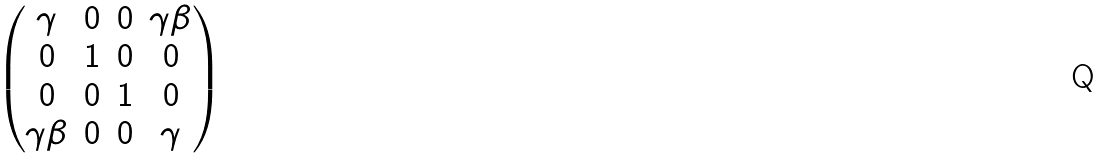<formula> <loc_0><loc_0><loc_500><loc_500>\begin{pmatrix} \gamma & 0 & 0 & \gamma \beta \\ 0 & 1 & 0 & 0 \\ 0 & 0 & 1 & 0 \\ \gamma \beta & 0 & 0 & \gamma \\ \end{pmatrix}</formula> 